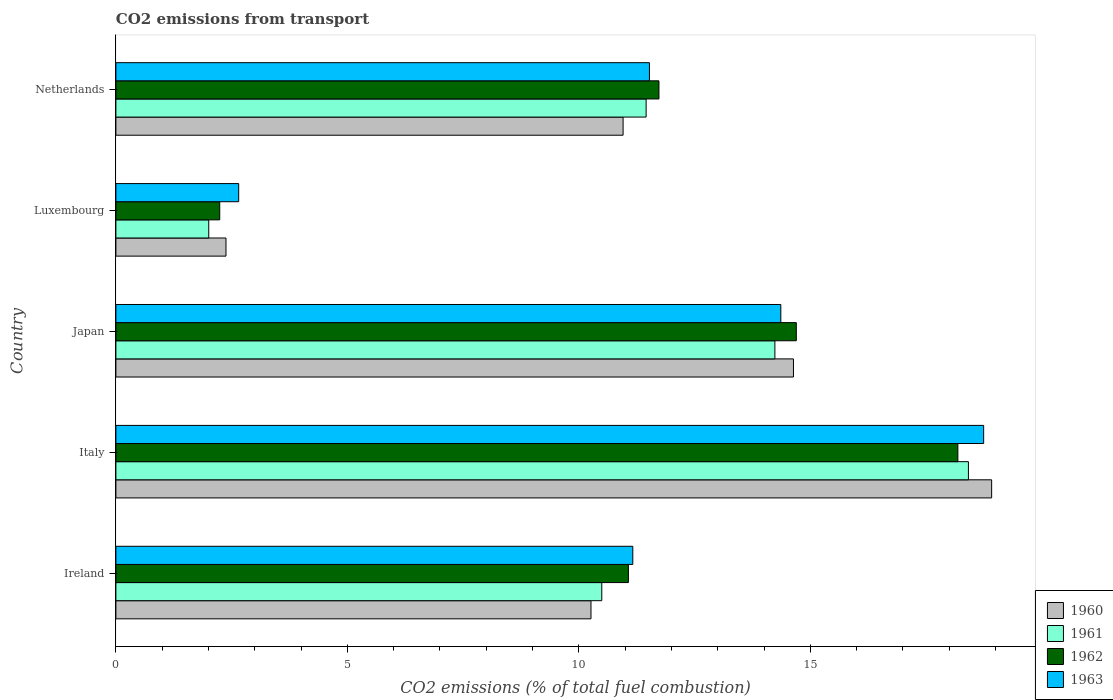How many different coloured bars are there?
Offer a terse response. 4. How many groups of bars are there?
Make the answer very short. 5. Are the number of bars per tick equal to the number of legend labels?
Provide a short and direct response. Yes. Are the number of bars on each tick of the Y-axis equal?
Ensure brevity in your answer.  Yes. How many bars are there on the 2nd tick from the top?
Your response must be concise. 4. How many bars are there on the 2nd tick from the bottom?
Offer a terse response. 4. What is the label of the 1st group of bars from the top?
Make the answer very short. Netherlands. In how many cases, is the number of bars for a given country not equal to the number of legend labels?
Your answer should be compact. 0. What is the total CO2 emitted in 1961 in Italy?
Your response must be concise. 18.42. Across all countries, what is the maximum total CO2 emitted in 1963?
Ensure brevity in your answer.  18.74. Across all countries, what is the minimum total CO2 emitted in 1961?
Provide a succinct answer. 2.01. In which country was the total CO2 emitted in 1961 minimum?
Provide a succinct answer. Luxembourg. What is the total total CO2 emitted in 1960 in the graph?
Provide a succinct answer. 57.15. What is the difference between the total CO2 emitted in 1962 in Italy and that in Netherlands?
Make the answer very short. 6.46. What is the difference between the total CO2 emitted in 1963 in Japan and the total CO2 emitted in 1960 in Ireland?
Your answer should be very brief. 4.1. What is the average total CO2 emitted in 1960 per country?
Give a very brief answer. 11.43. What is the difference between the total CO2 emitted in 1960 and total CO2 emitted in 1962 in Japan?
Keep it short and to the point. -0.06. In how many countries, is the total CO2 emitted in 1963 greater than 6 ?
Make the answer very short. 4. What is the ratio of the total CO2 emitted in 1960 in Italy to that in Luxembourg?
Make the answer very short. 7.95. Is the total CO2 emitted in 1961 in Italy less than that in Netherlands?
Provide a succinct answer. No. Is the difference between the total CO2 emitted in 1960 in Italy and Netherlands greater than the difference between the total CO2 emitted in 1962 in Italy and Netherlands?
Offer a very short reply. Yes. What is the difference between the highest and the second highest total CO2 emitted in 1961?
Offer a terse response. 4.18. What is the difference between the highest and the lowest total CO2 emitted in 1962?
Offer a very short reply. 15.94. In how many countries, is the total CO2 emitted in 1960 greater than the average total CO2 emitted in 1960 taken over all countries?
Offer a terse response. 2. Is the sum of the total CO2 emitted in 1962 in Luxembourg and Netherlands greater than the maximum total CO2 emitted in 1960 across all countries?
Offer a very short reply. No. Is it the case that in every country, the sum of the total CO2 emitted in 1963 and total CO2 emitted in 1960 is greater than the sum of total CO2 emitted in 1961 and total CO2 emitted in 1962?
Provide a short and direct response. No. What does the 4th bar from the bottom in Italy represents?
Keep it short and to the point. 1963. Is it the case that in every country, the sum of the total CO2 emitted in 1962 and total CO2 emitted in 1963 is greater than the total CO2 emitted in 1960?
Give a very brief answer. Yes. Are all the bars in the graph horizontal?
Ensure brevity in your answer.  Yes. How many countries are there in the graph?
Ensure brevity in your answer.  5. Are the values on the major ticks of X-axis written in scientific E-notation?
Your answer should be compact. No. Does the graph contain any zero values?
Offer a very short reply. No. How many legend labels are there?
Make the answer very short. 4. How are the legend labels stacked?
Ensure brevity in your answer.  Vertical. What is the title of the graph?
Your answer should be compact. CO2 emissions from transport. Does "2000" appear as one of the legend labels in the graph?
Give a very brief answer. No. What is the label or title of the X-axis?
Your answer should be very brief. CO2 emissions (% of total fuel combustion). What is the label or title of the Y-axis?
Offer a very short reply. Country. What is the CO2 emissions (% of total fuel combustion) in 1960 in Ireland?
Your response must be concise. 10.26. What is the CO2 emissions (% of total fuel combustion) of 1961 in Ireland?
Your answer should be compact. 10.5. What is the CO2 emissions (% of total fuel combustion) in 1962 in Ireland?
Provide a short and direct response. 11.07. What is the CO2 emissions (% of total fuel combustion) in 1963 in Ireland?
Offer a terse response. 11.17. What is the CO2 emissions (% of total fuel combustion) of 1960 in Italy?
Keep it short and to the point. 18.92. What is the CO2 emissions (% of total fuel combustion) in 1961 in Italy?
Offer a very short reply. 18.42. What is the CO2 emissions (% of total fuel combustion) of 1962 in Italy?
Your answer should be very brief. 18.19. What is the CO2 emissions (% of total fuel combustion) of 1963 in Italy?
Your answer should be compact. 18.74. What is the CO2 emissions (% of total fuel combustion) of 1960 in Japan?
Provide a succinct answer. 14.64. What is the CO2 emissions (% of total fuel combustion) of 1961 in Japan?
Ensure brevity in your answer.  14.23. What is the CO2 emissions (% of total fuel combustion) in 1962 in Japan?
Make the answer very short. 14.7. What is the CO2 emissions (% of total fuel combustion) of 1963 in Japan?
Ensure brevity in your answer.  14.36. What is the CO2 emissions (% of total fuel combustion) of 1960 in Luxembourg?
Offer a terse response. 2.38. What is the CO2 emissions (% of total fuel combustion) in 1961 in Luxembourg?
Give a very brief answer. 2.01. What is the CO2 emissions (% of total fuel combustion) in 1962 in Luxembourg?
Provide a short and direct response. 2.24. What is the CO2 emissions (% of total fuel combustion) in 1963 in Luxembourg?
Provide a short and direct response. 2.65. What is the CO2 emissions (% of total fuel combustion) in 1960 in Netherlands?
Your answer should be compact. 10.96. What is the CO2 emissions (% of total fuel combustion) of 1961 in Netherlands?
Provide a short and direct response. 11.45. What is the CO2 emissions (% of total fuel combustion) of 1962 in Netherlands?
Offer a very short reply. 11.73. What is the CO2 emissions (% of total fuel combustion) of 1963 in Netherlands?
Keep it short and to the point. 11.53. Across all countries, what is the maximum CO2 emissions (% of total fuel combustion) of 1960?
Make the answer very short. 18.92. Across all countries, what is the maximum CO2 emissions (% of total fuel combustion) of 1961?
Ensure brevity in your answer.  18.42. Across all countries, what is the maximum CO2 emissions (% of total fuel combustion) in 1962?
Your response must be concise. 18.19. Across all countries, what is the maximum CO2 emissions (% of total fuel combustion) in 1963?
Ensure brevity in your answer.  18.74. Across all countries, what is the minimum CO2 emissions (% of total fuel combustion) of 1960?
Provide a succinct answer. 2.38. Across all countries, what is the minimum CO2 emissions (% of total fuel combustion) in 1961?
Offer a very short reply. 2.01. Across all countries, what is the minimum CO2 emissions (% of total fuel combustion) in 1962?
Give a very brief answer. 2.24. Across all countries, what is the minimum CO2 emissions (% of total fuel combustion) of 1963?
Your answer should be very brief. 2.65. What is the total CO2 emissions (% of total fuel combustion) of 1960 in the graph?
Your response must be concise. 57.15. What is the total CO2 emissions (% of total fuel combustion) of 1961 in the graph?
Your answer should be very brief. 56.61. What is the total CO2 emissions (% of total fuel combustion) in 1962 in the graph?
Your answer should be very brief. 57.93. What is the total CO2 emissions (% of total fuel combustion) in 1963 in the graph?
Provide a short and direct response. 58.45. What is the difference between the CO2 emissions (% of total fuel combustion) in 1960 in Ireland and that in Italy?
Offer a very short reply. -8.65. What is the difference between the CO2 emissions (% of total fuel combustion) of 1961 in Ireland and that in Italy?
Provide a succinct answer. -7.92. What is the difference between the CO2 emissions (% of total fuel combustion) of 1962 in Ireland and that in Italy?
Ensure brevity in your answer.  -7.12. What is the difference between the CO2 emissions (% of total fuel combustion) in 1963 in Ireland and that in Italy?
Offer a very short reply. -7.58. What is the difference between the CO2 emissions (% of total fuel combustion) of 1960 in Ireland and that in Japan?
Provide a succinct answer. -4.37. What is the difference between the CO2 emissions (% of total fuel combustion) of 1961 in Ireland and that in Japan?
Ensure brevity in your answer.  -3.74. What is the difference between the CO2 emissions (% of total fuel combustion) in 1962 in Ireland and that in Japan?
Your response must be concise. -3.63. What is the difference between the CO2 emissions (% of total fuel combustion) of 1963 in Ireland and that in Japan?
Your answer should be compact. -3.2. What is the difference between the CO2 emissions (% of total fuel combustion) in 1960 in Ireland and that in Luxembourg?
Your response must be concise. 7.88. What is the difference between the CO2 emissions (% of total fuel combustion) of 1961 in Ireland and that in Luxembourg?
Give a very brief answer. 8.49. What is the difference between the CO2 emissions (% of total fuel combustion) in 1962 in Ireland and that in Luxembourg?
Give a very brief answer. 8.83. What is the difference between the CO2 emissions (% of total fuel combustion) of 1963 in Ireland and that in Luxembourg?
Make the answer very short. 8.51. What is the difference between the CO2 emissions (% of total fuel combustion) in 1960 in Ireland and that in Netherlands?
Your answer should be very brief. -0.69. What is the difference between the CO2 emissions (% of total fuel combustion) of 1961 in Ireland and that in Netherlands?
Your answer should be very brief. -0.96. What is the difference between the CO2 emissions (% of total fuel combustion) of 1962 in Ireland and that in Netherlands?
Offer a very short reply. -0.66. What is the difference between the CO2 emissions (% of total fuel combustion) of 1963 in Ireland and that in Netherlands?
Keep it short and to the point. -0.36. What is the difference between the CO2 emissions (% of total fuel combustion) in 1960 in Italy and that in Japan?
Your answer should be very brief. 4.28. What is the difference between the CO2 emissions (% of total fuel combustion) in 1961 in Italy and that in Japan?
Offer a very short reply. 4.18. What is the difference between the CO2 emissions (% of total fuel combustion) in 1962 in Italy and that in Japan?
Offer a very short reply. 3.49. What is the difference between the CO2 emissions (% of total fuel combustion) of 1963 in Italy and that in Japan?
Provide a succinct answer. 4.38. What is the difference between the CO2 emissions (% of total fuel combustion) of 1960 in Italy and that in Luxembourg?
Your answer should be very brief. 16.54. What is the difference between the CO2 emissions (% of total fuel combustion) in 1961 in Italy and that in Luxembourg?
Provide a short and direct response. 16.41. What is the difference between the CO2 emissions (% of total fuel combustion) of 1962 in Italy and that in Luxembourg?
Make the answer very short. 15.94. What is the difference between the CO2 emissions (% of total fuel combustion) of 1963 in Italy and that in Luxembourg?
Offer a very short reply. 16.09. What is the difference between the CO2 emissions (% of total fuel combustion) in 1960 in Italy and that in Netherlands?
Your answer should be compact. 7.96. What is the difference between the CO2 emissions (% of total fuel combustion) of 1961 in Italy and that in Netherlands?
Offer a very short reply. 6.96. What is the difference between the CO2 emissions (% of total fuel combustion) of 1962 in Italy and that in Netherlands?
Offer a very short reply. 6.46. What is the difference between the CO2 emissions (% of total fuel combustion) of 1963 in Italy and that in Netherlands?
Give a very brief answer. 7.22. What is the difference between the CO2 emissions (% of total fuel combustion) of 1960 in Japan and that in Luxembourg?
Ensure brevity in your answer.  12.26. What is the difference between the CO2 emissions (% of total fuel combustion) of 1961 in Japan and that in Luxembourg?
Offer a terse response. 12.23. What is the difference between the CO2 emissions (% of total fuel combustion) in 1962 in Japan and that in Luxembourg?
Keep it short and to the point. 12.45. What is the difference between the CO2 emissions (% of total fuel combustion) in 1963 in Japan and that in Luxembourg?
Make the answer very short. 11.71. What is the difference between the CO2 emissions (% of total fuel combustion) in 1960 in Japan and that in Netherlands?
Provide a short and direct response. 3.68. What is the difference between the CO2 emissions (% of total fuel combustion) of 1961 in Japan and that in Netherlands?
Give a very brief answer. 2.78. What is the difference between the CO2 emissions (% of total fuel combustion) of 1962 in Japan and that in Netherlands?
Make the answer very short. 2.97. What is the difference between the CO2 emissions (% of total fuel combustion) in 1963 in Japan and that in Netherlands?
Your response must be concise. 2.84. What is the difference between the CO2 emissions (% of total fuel combustion) of 1960 in Luxembourg and that in Netherlands?
Provide a short and direct response. -8.58. What is the difference between the CO2 emissions (% of total fuel combustion) of 1961 in Luxembourg and that in Netherlands?
Your answer should be compact. -9.45. What is the difference between the CO2 emissions (% of total fuel combustion) in 1962 in Luxembourg and that in Netherlands?
Provide a short and direct response. -9.49. What is the difference between the CO2 emissions (% of total fuel combustion) in 1963 in Luxembourg and that in Netherlands?
Your answer should be compact. -8.87. What is the difference between the CO2 emissions (% of total fuel combustion) in 1960 in Ireland and the CO2 emissions (% of total fuel combustion) in 1961 in Italy?
Give a very brief answer. -8.15. What is the difference between the CO2 emissions (% of total fuel combustion) in 1960 in Ireland and the CO2 emissions (% of total fuel combustion) in 1962 in Italy?
Offer a very short reply. -7.92. What is the difference between the CO2 emissions (% of total fuel combustion) of 1960 in Ireland and the CO2 emissions (% of total fuel combustion) of 1963 in Italy?
Offer a very short reply. -8.48. What is the difference between the CO2 emissions (% of total fuel combustion) in 1961 in Ireland and the CO2 emissions (% of total fuel combustion) in 1962 in Italy?
Offer a terse response. -7.69. What is the difference between the CO2 emissions (% of total fuel combustion) in 1961 in Ireland and the CO2 emissions (% of total fuel combustion) in 1963 in Italy?
Your response must be concise. -8.25. What is the difference between the CO2 emissions (% of total fuel combustion) in 1962 in Ireland and the CO2 emissions (% of total fuel combustion) in 1963 in Italy?
Provide a succinct answer. -7.67. What is the difference between the CO2 emissions (% of total fuel combustion) in 1960 in Ireland and the CO2 emissions (% of total fuel combustion) in 1961 in Japan?
Offer a very short reply. -3.97. What is the difference between the CO2 emissions (% of total fuel combustion) of 1960 in Ireland and the CO2 emissions (% of total fuel combustion) of 1962 in Japan?
Offer a very short reply. -4.44. What is the difference between the CO2 emissions (% of total fuel combustion) of 1960 in Ireland and the CO2 emissions (% of total fuel combustion) of 1963 in Japan?
Keep it short and to the point. -4.1. What is the difference between the CO2 emissions (% of total fuel combustion) in 1961 in Ireland and the CO2 emissions (% of total fuel combustion) in 1962 in Japan?
Your answer should be compact. -4.2. What is the difference between the CO2 emissions (% of total fuel combustion) of 1961 in Ireland and the CO2 emissions (% of total fuel combustion) of 1963 in Japan?
Offer a terse response. -3.87. What is the difference between the CO2 emissions (% of total fuel combustion) of 1962 in Ireland and the CO2 emissions (% of total fuel combustion) of 1963 in Japan?
Your response must be concise. -3.29. What is the difference between the CO2 emissions (% of total fuel combustion) of 1960 in Ireland and the CO2 emissions (% of total fuel combustion) of 1961 in Luxembourg?
Make the answer very short. 8.26. What is the difference between the CO2 emissions (% of total fuel combustion) of 1960 in Ireland and the CO2 emissions (% of total fuel combustion) of 1962 in Luxembourg?
Your answer should be compact. 8.02. What is the difference between the CO2 emissions (% of total fuel combustion) of 1960 in Ireland and the CO2 emissions (% of total fuel combustion) of 1963 in Luxembourg?
Provide a short and direct response. 7.61. What is the difference between the CO2 emissions (% of total fuel combustion) of 1961 in Ireland and the CO2 emissions (% of total fuel combustion) of 1962 in Luxembourg?
Give a very brief answer. 8.25. What is the difference between the CO2 emissions (% of total fuel combustion) of 1961 in Ireland and the CO2 emissions (% of total fuel combustion) of 1963 in Luxembourg?
Provide a short and direct response. 7.84. What is the difference between the CO2 emissions (% of total fuel combustion) of 1962 in Ireland and the CO2 emissions (% of total fuel combustion) of 1963 in Luxembourg?
Your response must be concise. 8.42. What is the difference between the CO2 emissions (% of total fuel combustion) in 1960 in Ireland and the CO2 emissions (% of total fuel combustion) in 1961 in Netherlands?
Give a very brief answer. -1.19. What is the difference between the CO2 emissions (% of total fuel combustion) of 1960 in Ireland and the CO2 emissions (% of total fuel combustion) of 1962 in Netherlands?
Make the answer very short. -1.47. What is the difference between the CO2 emissions (% of total fuel combustion) of 1960 in Ireland and the CO2 emissions (% of total fuel combustion) of 1963 in Netherlands?
Your response must be concise. -1.26. What is the difference between the CO2 emissions (% of total fuel combustion) of 1961 in Ireland and the CO2 emissions (% of total fuel combustion) of 1962 in Netherlands?
Your answer should be very brief. -1.24. What is the difference between the CO2 emissions (% of total fuel combustion) in 1961 in Ireland and the CO2 emissions (% of total fuel combustion) in 1963 in Netherlands?
Provide a succinct answer. -1.03. What is the difference between the CO2 emissions (% of total fuel combustion) of 1962 in Ireland and the CO2 emissions (% of total fuel combustion) of 1963 in Netherlands?
Offer a terse response. -0.45. What is the difference between the CO2 emissions (% of total fuel combustion) of 1960 in Italy and the CO2 emissions (% of total fuel combustion) of 1961 in Japan?
Your answer should be compact. 4.68. What is the difference between the CO2 emissions (% of total fuel combustion) in 1960 in Italy and the CO2 emissions (% of total fuel combustion) in 1962 in Japan?
Your answer should be compact. 4.22. What is the difference between the CO2 emissions (% of total fuel combustion) of 1960 in Italy and the CO2 emissions (% of total fuel combustion) of 1963 in Japan?
Your answer should be very brief. 4.55. What is the difference between the CO2 emissions (% of total fuel combustion) in 1961 in Italy and the CO2 emissions (% of total fuel combustion) in 1962 in Japan?
Your answer should be compact. 3.72. What is the difference between the CO2 emissions (% of total fuel combustion) in 1961 in Italy and the CO2 emissions (% of total fuel combustion) in 1963 in Japan?
Ensure brevity in your answer.  4.05. What is the difference between the CO2 emissions (% of total fuel combustion) in 1962 in Italy and the CO2 emissions (% of total fuel combustion) in 1963 in Japan?
Your answer should be very brief. 3.82. What is the difference between the CO2 emissions (% of total fuel combustion) in 1960 in Italy and the CO2 emissions (% of total fuel combustion) in 1961 in Luxembourg?
Ensure brevity in your answer.  16.91. What is the difference between the CO2 emissions (% of total fuel combustion) of 1960 in Italy and the CO2 emissions (% of total fuel combustion) of 1962 in Luxembourg?
Give a very brief answer. 16.67. What is the difference between the CO2 emissions (% of total fuel combustion) of 1960 in Italy and the CO2 emissions (% of total fuel combustion) of 1963 in Luxembourg?
Ensure brevity in your answer.  16.26. What is the difference between the CO2 emissions (% of total fuel combustion) in 1961 in Italy and the CO2 emissions (% of total fuel combustion) in 1962 in Luxembourg?
Ensure brevity in your answer.  16.17. What is the difference between the CO2 emissions (% of total fuel combustion) of 1961 in Italy and the CO2 emissions (% of total fuel combustion) of 1963 in Luxembourg?
Provide a short and direct response. 15.76. What is the difference between the CO2 emissions (% of total fuel combustion) in 1962 in Italy and the CO2 emissions (% of total fuel combustion) in 1963 in Luxembourg?
Provide a short and direct response. 15.53. What is the difference between the CO2 emissions (% of total fuel combustion) in 1960 in Italy and the CO2 emissions (% of total fuel combustion) in 1961 in Netherlands?
Offer a very short reply. 7.46. What is the difference between the CO2 emissions (% of total fuel combustion) in 1960 in Italy and the CO2 emissions (% of total fuel combustion) in 1962 in Netherlands?
Keep it short and to the point. 7.19. What is the difference between the CO2 emissions (% of total fuel combustion) of 1960 in Italy and the CO2 emissions (% of total fuel combustion) of 1963 in Netherlands?
Keep it short and to the point. 7.39. What is the difference between the CO2 emissions (% of total fuel combustion) of 1961 in Italy and the CO2 emissions (% of total fuel combustion) of 1962 in Netherlands?
Your answer should be very brief. 6.68. What is the difference between the CO2 emissions (% of total fuel combustion) of 1961 in Italy and the CO2 emissions (% of total fuel combustion) of 1963 in Netherlands?
Provide a succinct answer. 6.89. What is the difference between the CO2 emissions (% of total fuel combustion) in 1962 in Italy and the CO2 emissions (% of total fuel combustion) in 1963 in Netherlands?
Offer a very short reply. 6.66. What is the difference between the CO2 emissions (% of total fuel combustion) in 1960 in Japan and the CO2 emissions (% of total fuel combustion) in 1961 in Luxembourg?
Ensure brevity in your answer.  12.63. What is the difference between the CO2 emissions (% of total fuel combustion) in 1960 in Japan and the CO2 emissions (% of total fuel combustion) in 1962 in Luxembourg?
Offer a very short reply. 12.39. What is the difference between the CO2 emissions (% of total fuel combustion) of 1960 in Japan and the CO2 emissions (% of total fuel combustion) of 1963 in Luxembourg?
Offer a very short reply. 11.98. What is the difference between the CO2 emissions (% of total fuel combustion) in 1961 in Japan and the CO2 emissions (% of total fuel combustion) in 1962 in Luxembourg?
Your answer should be compact. 11.99. What is the difference between the CO2 emissions (% of total fuel combustion) of 1961 in Japan and the CO2 emissions (% of total fuel combustion) of 1963 in Luxembourg?
Give a very brief answer. 11.58. What is the difference between the CO2 emissions (% of total fuel combustion) in 1962 in Japan and the CO2 emissions (% of total fuel combustion) in 1963 in Luxembourg?
Your response must be concise. 12.05. What is the difference between the CO2 emissions (% of total fuel combustion) of 1960 in Japan and the CO2 emissions (% of total fuel combustion) of 1961 in Netherlands?
Provide a succinct answer. 3.18. What is the difference between the CO2 emissions (% of total fuel combustion) of 1960 in Japan and the CO2 emissions (% of total fuel combustion) of 1962 in Netherlands?
Offer a terse response. 2.91. What is the difference between the CO2 emissions (% of total fuel combustion) of 1960 in Japan and the CO2 emissions (% of total fuel combustion) of 1963 in Netherlands?
Your answer should be compact. 3.11. What is the difference between the CO2 emissions (% of total fuel combustion) in 1961 in Japan and the CO2 emissions (% of total fuel combustion) in 1962 in Netherlands?
Offer a terse response. 2.5. What is the difference between the CO2 emissions (% of total fuel combustion) of 1961 in Japan and the CO2 emissions (% of total fuel combustion) of 1963 in Netherlands?
Make the answer very short. 2.71. What is the difference between the CO2 emissions (% of total fuel combustion) of 1962 in Japan and the CO2 emissions (% of total fuel combustion) of 1963 in Netherlands?
Offer a very short reply. 3.17. What is the difference between the CO2 emissions (% of total fuel combustion) of 1960 in Luxembourg and the CO2 emissions (% of total fuel combustion) of 1961 in Netherlands?
Ensure brevity in your answer.  -9.08. What is the difference between the CO2 emissions (% of total fuel combustion) in 1960 in Luxembourg and the CO2 emissions (% of total fuel combustion) in 1962 in Netherlands?
Provide a short and direct response. -9.35. What is the difference between the CO2 emissions (% of total fuel combustion) in 1960 in Luxembourg and the CO2 emissions (% of total fuel combustion) in 1963 in Netherlands?
Your response must be concise. -9.15. What is the difference between the CO2 emissions (% of total fuel combustion) of 1961 in Luxembourg and the CO2 emissions (% of total fuel combustion) of 1962 in Netherlands?
Offer a very short reply. -9.72. What is the difference between the CO2 emissions (% of total fuel combustion) in 1961 in Luxembourg and the CO2 emissions (% of total fuel combustion) in 1963 in Netherlands?
Provide a succinct answer. -9.52. What is the difference between the CO2 emissions (% of total fuel combustion) of 1962 in Luxembourg and the CO2 emissions (% of total fuel combustion) of 1963 in Netherlands?
Your answer should be very brief. -9.28. What is the average CO2 emissions (% of total fuel combustion) in 1960 per country?
Ensure brevity in your answer.  11.43. What is the average CO2 emissions (% of total fuel combustion) in 1961 per country?
Ensure brevity in your answer.  11.32. What is the average CO2 emissions (% of total fuel combustion) of 1962 per country?
Ensure brevity in your answer.  11.59. What is the average CO2 emissions (% of total fuel combustion) in 1963 per country?
Your answer should be compact. 11.69. What is the difference between the CO2 emissions (% of total fuel combustion) of 1960 and CO2 emissions (% of total fuel combustion) of 1961 in Ireland?
Provide a short and direct response. -0.23. What is the difference between the CO2 emissions (% of total fuel combustion) of 1960 and CO2 emissions (% of total fuel combustion) of 1962 in Ireland?
Make the answer very short. -0.81. What is the difference between the CO2 emissions (% of total fuel combustion) in 1960 and CO2 emissions (% of total fuel combustion) in 1963 in Ireland?
Provide a short and direct response. -0.9. What is the difference between the CO2 emissions (% of total fuel combustion) in 1961 and CO2 emissions (% of total fuel combustion) in 1962 in Ireland?
Your response must be concise. -0.58. What is the difference between the CO2 emissions (% of total fuel combustion) in 1961 and CO2 emissions (% of total fuel combustion) in 1963 in Ireland?
Keep it short and to the point. -0.67. What is the difference between the CO2 emissions (% of total fuel combustion) of 1962 and CO2 emissions (% of total fuel combustion) of 1963 in Ireland?
Offer a terse response. -0.09. What is the difference between the CO2 emissions (% of total fuel combustion) in 1960 and CO2 emissions (% of total fuel combustion) in 1961 in Italy?
Your answer should be compact. 0.5. What is the difference between the CO2 emissions (% of total fuel combustion) in 1960 and CO2 emissions (% of total fuel combustion) in 1962 in Italy?
Provide a short and direct response. 0.73. What is the difference between the CO2 emissions (% of total fuel combustion) of 1960 and CO2 emissions (% of total fuel combustion) of 1963 in Italy?
Make the answer very short. 0.17. What is the difference between the CO2 emissions (% of total fuel combustion) of 1961 and CO2 emissions (% of total fuel combustion) of 1962 in Italy?
Keep it short and to the point. 0.23. What is the difference between the CO2 emissions (% of total fuel combustion) of 1961 and CO2 emissions (% of total fuel combustion) of 1963 in Italy?
Your answer should be compact. -0.33. What is the difference between the CO2 emissions (% of total fuel combustion) in 1962 and CO2 emissions (% of total fuel combustion) in 1963 in Italy?
Provide a succinct answer. -0.56. What is the difference between the CO2 emissions (% of total fuel combustion) of 1960 and CO2 emissions (% of total fuel combustion) of 1961 in Japan?
Provide a succinct answer. 0.4. What is the difference between the CO2 emissions (% of total fuel combustion) of 1960 and CO2 emissions (% of total fuel combustion) of 1962 in Japan?
Give a very brief answer. -0.06. What is the difference between the CO2 emissions (% of total fuel combustion) of 1960 and CO2 emissions (% of total fuel combustion) of 1963 in Japan?
Provide a succinct answer. 0.27. What is the difference between the CO2 emissions (% of total fuel combustion) of 1961 and CO2 emissions (% of total fuel combustion) of 1962 in Japan?
Ensure brevity in your answer.  -0.46. What is the difference between the CO2 emissions (% of total fuel combustion) of 1961 and CO2 emissions (% of total fuel combustion) of 1963 in Japan?
Make the answer very short. -0.13. What is the difference between the CO2 emissions (% of total fuel combustion) in 1962 and CO2 emissions (% of total fuel combustion) in 1963 in Japan?
Your answer should be very brief. 0.33. What is the difference between the CO2 emissions (% of total fuel combustion) of 1960 and CO2 emissions (% of total fuel combustion) of 1961 in Luxembourg?
Your response must be concise. 0.37. What is the difference between the CO2 emissions (% of total fuel combustion) of 1960 and CO2 emissions (% of total fuel combustion) of 1962 in Luxembourg?
Your answer should be very brief. 0.14. What is the difference between the CO2 emissions (% of total fuel combustion) of 1960 and CO2 emissions (% of total fuel combustion) of 1963 in Luxembourg?
Offer a terse response. -0.27. What is the difference between the CO2 emissions (% of total fuel combustion) of 1961 and CO2 emissions (% of total fuel combustion) of 1962 in Luxembourg?
Make the answer very short. -0.24. What is the difference between the CO2 emissions (% of total fuel combustion) of 1961 and CO2 emissions (% of total fuel combustion) of 1963 in Luxembourg?
Offer a very short reply. -0.65. What is the difference between the CO2 emissions (% of total fuel combustion) in 1962 and CO2 emissions (% of total fuel combustion) in 1963 in Luxembourg?
Your answer should be very brief. -0.41. What is the difference between the CO2 emissions (% of total fuel combustion) of 1960 and CO2 emissions (% of total fuel combustion) of 1961 in Netherlands?
Provide a short and direct response. -0.5. What is the difference between the CO2 emissions (% of total fuel combustion) of 1960 and CO2 emissions (% of total fuel combustion) of 1962 in Netherlands?
Your answer should be very brief. -0.77. What is the difference between the CO2 emissions (% of total fuel combustion) in 1960 and CO2 emissions (% of total fuel combustion) in 1963 in Netherlands?
Offer a terse response. -0.57. What is the difference between the CO2 emissions (% of total fuel combustion) in 1961 and CO2 emissions (% of total fuel combustion) in 1962 in Netherlands?
Your response must be concise. -0.28. What is the difference between the CO2 emissions (% of total fuel combustion) of 1961 and CO2 emissions (% of total fuel combustion) of 1963 in Netherlands?
Keep it short and to the point. -0.07. What is the difference between the CO2 emissions (% of total fuel combustion) of 1962 and CO2 emissions (% of total fuel combustion) of 1963 in Netherlands?
Give a very brief answer. 0.21. What is the ratio of the CO2 emissions (% of total fuel combustion) in 1960 in Ireland to that in Italy?
Give a very brief answer. 0.54. What is the ratio of the CO2 emissions (% of total fuel combustion) in 1961 in Ireland to that in Italy?
Give a very brief answer. 0.57. What is the ratio of the CO2 emissions (% of total fuel combustion) of 1962 in Ireland to that in Italy?
Your answer should be compact. 0.61. What is the ratio of the CO2 emissions (% of total fuel combustion) in 1963 in Ireland to that in Italy?
Ensure brevity in your answer.  0.6. What is the ratio of the CO2 emissions (% of total fuel combustion) of 1960 in Ireland to that in Japan?
Keep it short and to the point. 0.7. What is the ratio of the CO2 emissions (% of total fuel combustion) in 1961 in Ireland to that in Japan?
Keep it short and to the point. 0.74. What is the ratio of the CO2 emissions (% of total fuel combustion) in 1962 in Ireland to that in Japan?
Offer a terse response. 0.75. What is the ratio of the CO2 emissions (% of total fuel combustion) in 1963 in Ireland to that in Japan?
Give a very brief answer. 0.78. What is the ratio of the CO2 emissions (% of total fuel combustion) in 1960 in Ireland to that in Luxembourg?
Your answer should be compact. 4.32. What is the ratio of the CO2 emissions (% of total fuel combustion) of 1961 in Ireland to that in Luxembourg?
Your answer should be compact. 5.23. What is the ratio of the CO2 emissions (% of total fuel combustion) of 1962 in Ireland to that in Luxembourg?
Provide a short and direct response. 4.94. What is the ratio of the CO2 emissions (% of total fuel combustion) in 1963 in Ireland to that in Luxembourg?
Offer a terse response. 4.21. What is the ratio of the CO2 emissions (% of total fuel combustion) in 1960 in Ireland to that in Netherlands?
Provide a short and direct response. 0.94. What is the ratio of the CO2 emissions (% of total fuel combustion) in 1961 in Ireland to that in Netherlands?
Your response must be concise. 0.92. What is the ratio of the CO2 emissions (% of total fuel combustion) in 1962 in Ireland to that in Netherlands?
Give a very brief answer. 0.94. What is the ratio of the CO2 emissions (% of total fuel combustion) in 1963 in Ireland to that in Netherlands?
Provide a succinct answer. 0.97. What is the ratio of the CO2 emissions (% of total fuel combustion) in 1960 in Italy to that in Japan?
Your answer should be compact. 1.29. What is the ratio of the CO2 emissions (% of total fuel combustion) of 1961 in Italy to that in Japan?
Provide a succinct answer. 1.29. What is the ratio of the CO2 emissions (% of total fuel combustion) of 1962 in Italy to that in Japan?
Make the answer very short. 1.24. What is the ratio of the CO2 emissions (% of total fuel combustion) in 1963 in Italy to that in Japan?
Make the answer very short. 1.31. What is the ratio of the CO2 emissions (% of total fuel combustion) of 1960 in Italy to that in Luxembourg?
Keep it short and to the point. 7.95. What is the ratio of the CO2 emissions (% of total fuel combustion) of 1961 in Italy to that in Luxembourg?
Offer a terse response. 9.18. What is the ratio of the CO2 emissions (% of total fuel combustion) of 1962 in Italy to that in Luxembourg?
Provide a short and direct response. 8.11. What is the ratio of the CO2 emissions (% of total fuel combustion) of 1963 in Italy to that in Luxembourg?
Offer a very short reply. 7.07. What is the ratio of the CO2 emissions (% of total fuel combustion) of 1960 in Italy to that in Netherlands?
Provide a succinct answer. 1.73. What is the ratio of the CO2 emissions (% of total fuel combustion) in 1961 in Italy to that in Netherlands?
Your answer should be very brief. 1.61. What is the ratio of the CO2 emissions (% of total fuel combustion) in 1962 in Italy to that in Netherlands?
Offer a terse response. 1.55. What is the ratio of the CO2 emissions (% of total fuel combustion) in 1963 in Italy to that in Netherlands?
Your answer should be very brief. 1.63. What is the ratio of the CO2 emissions (% of total fuel combustion) in 1960 in Japan to that in Luxembourg?
Give a very brief answer. 6.15. What is the ratio of the CO2 emissions (% of total fuel combustion) of 1961 in Japan to that in Luxembourg?
Provide a succinct answer. 7.1. What is the ratio of the CO2 emissions (% of total fuel combustion) of 1962 in Japan to that in Luxembourg?
Give a very brief answer. 6.55. What is the ratio of the CO2 emissions (% of total fuel combustion) of 1963 in Japan to that in Luxembourg?
Make the answer very short. 5.41. What is the ratio of the CO2 emissions (% of total fuel combustion) of 1960 in Japan to that in Netherlands?
Your answer should be compact. 1.34. What is the ratio of the CO2 emissions (% of total fuel combustion) in 1961 in Japan to that in Netherlands?
Ensure brevity in your answer.  1.24. What is the ratio of the CO2 emissions (% of total fuel combustion) of 1962 in Japan to that in Netherlands?
Provide a succinct answer. 1.25. What is the ratio of the CO2 emissions (% of total fuel combustion) of 1963 in Japan to that in Netherlands?
Offer a terse response. 1.25. What is the ratio of the CO2 emissions (% of total fuel combustion) of 1960 in Luxembourg to that in Netherlands?
Your response must be concise. 0.22. What is the ratio of the CO2 emissions (% of total fuel combustion) of 1961 in Luxembourg to that in Netherlands?
Your response must be concise. 0.18. What is the ratio of the CO2 emissions (% of total fuel combustion) of 1962 in Luxembourg to that in Netherlands?
Provide a succinct answer. 0.19. What is the ratio of the CO2 emissions (% of total fuel combustion) of 1963 in Luxembourg to that in Netherlands?
Provide a succinct answer. 0.23. What is the difference between the highest and the second highest CO2 emissions (% of total fuel combustion) of 1960?
Your response must be concise. 4.28. What is the difference between the highest and the second highest CO2 emissions (% of total fuel combustion) of 1961?
Offer a terse response. 4.18. What is the difference between the highest and the second highest CO2 emissions (% of total fuel combustion) in 1962?
Offer a very short reply. 3.49. What is the difference between the highest and the second highest CO2 emissions (% of total fuel combustion) in 1963?
Your answer should be very brief. 4.38. What is the difference between the highest and the lowest CO2 emissions (% of total fuel combustion) of 1960?
Make the answer very short. 16.54. What is the difference between the highest and the lowest CO2 emissions (% of total fuel combustion) of 1961?
Your response must be concise. 16.41. What is the difference between the highest and the lowest CO2 emissions (% of total fuel combustion) in 1962?
Make the answer very short. 15.94. What is the difference between the highest and the lowest CO2 emissions (% of total fuel combustion) in 1963?
Provide a succinct answer. 16.09. 